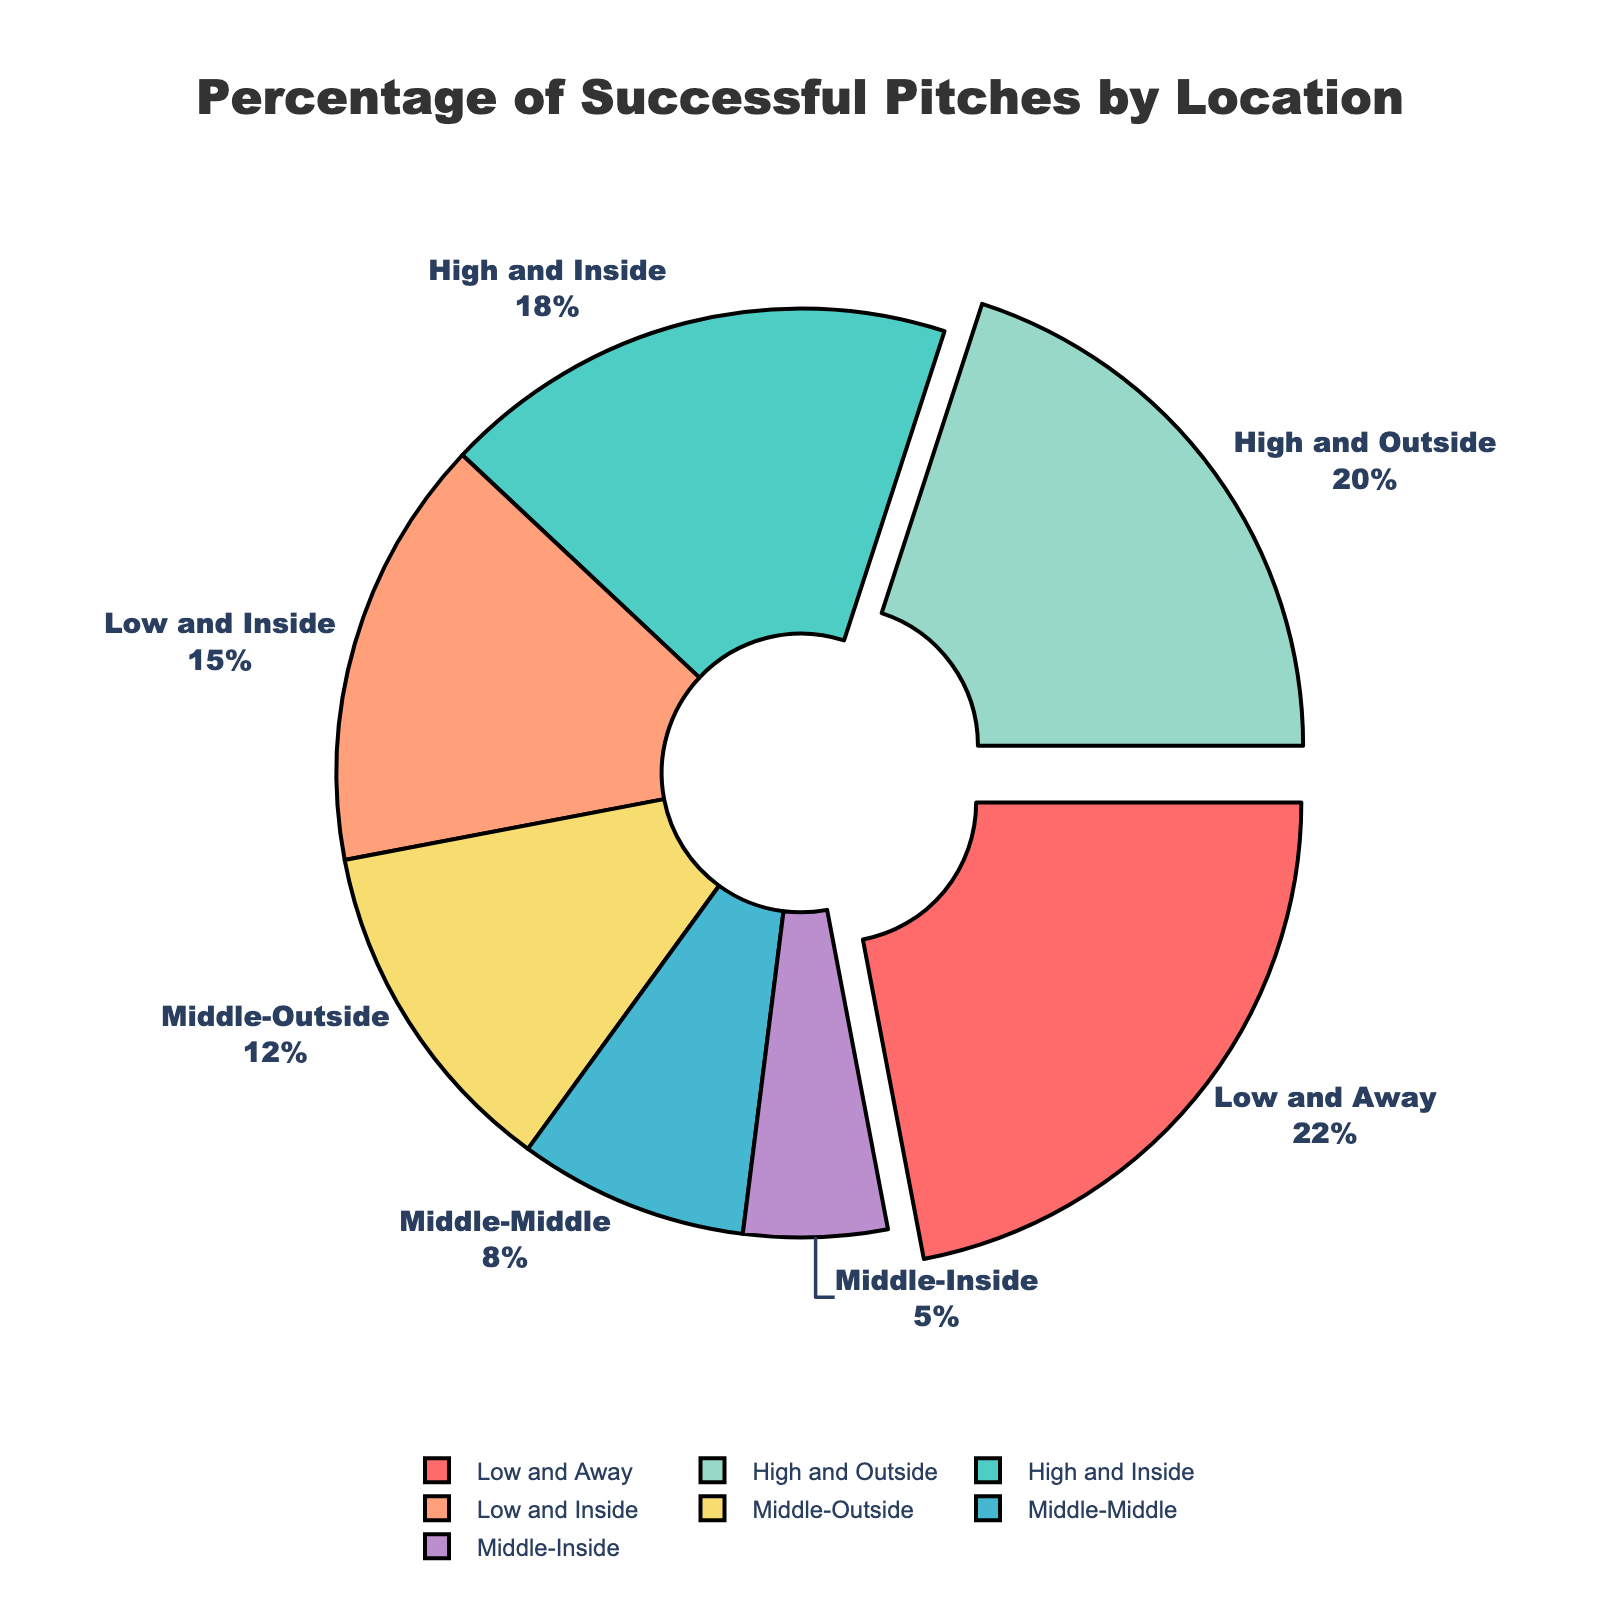What's the most successful pitch location in the strike zone? The pie chart shows the percentage of successful pitches by location. The section with the highest percentage will be the answer. The "Low and Away" section takes up the largest portion with 22%.
Answer: Low and Away Which pitch locations have a success rate higher than 15%? By referring to the percentages next to each section of the pie chart, the locations with success rates higher than 15% are "Low and Away" (22%), "High and Outside" (20%), and "High and Inside" (18%).
Answer: Low and Away, High and Outside, High and Inside What is the combined percentage of successful pitches for middle locations (Middle-Middle, Middle-Outside, Middle-Inside)? To find the combined percentage, sum the percentages of all middle locations: Middle-Middle (8%), Middle-Outside (12%), and Middle-Inside (5%) which adds up to 8 + 12 + 5 = 25%.
Answer: 25% Which pitch location has the lowest success rate? The smallest section of the pie chart represents the location with the lowest percentage. The "Middle-Inside" section is the smallest and has a 5% success rate.
Answer: Middle-Inside What are the visual differences between locations with 20% success and those with 8%? By referring to the visual attributes, we see that the section labeled "High and Outside" at 20% is significantly larger than "Middle-Middle" at 8%. Also, the "High and Outside" section is green, while the "Middle-Middle" section is blue.
Answer: Larger section and different colors How many pitch locations have success rates between 8% and 20%? By analyzing the pie chart, the locations with percentages between 8% and 20% are "High and Inside" (18%), "Low and Inside" (15%), "Middle-Outside" (12%). This gives us 3 locations.
Answer: 3 What is the difference in success rate between the "Low and Inside" and "High and Outside" pitches? Subtract the success rate of "Low and Inside" (15%) from "High and Outside" (20%) to find the difference, which is 20% - 15% = 5%.
Answer: 5% Which two pitch locations contribute equally to the pie chart? By examining the pie chart sections, the two locations that have the same percentage of contribution are "Middle-Outside" and "High and Inside", each contributing 12% and 18% respectively doesn't have an equal contribution. Reassessing this question and finding no equal contribution exists.
Answer: None Which pitch location is represented in orange? By visual inspection, the orange section on the pie chart corresponds to "Low and Inside" which has a 15% success rate.
Answer: Low and Inside 